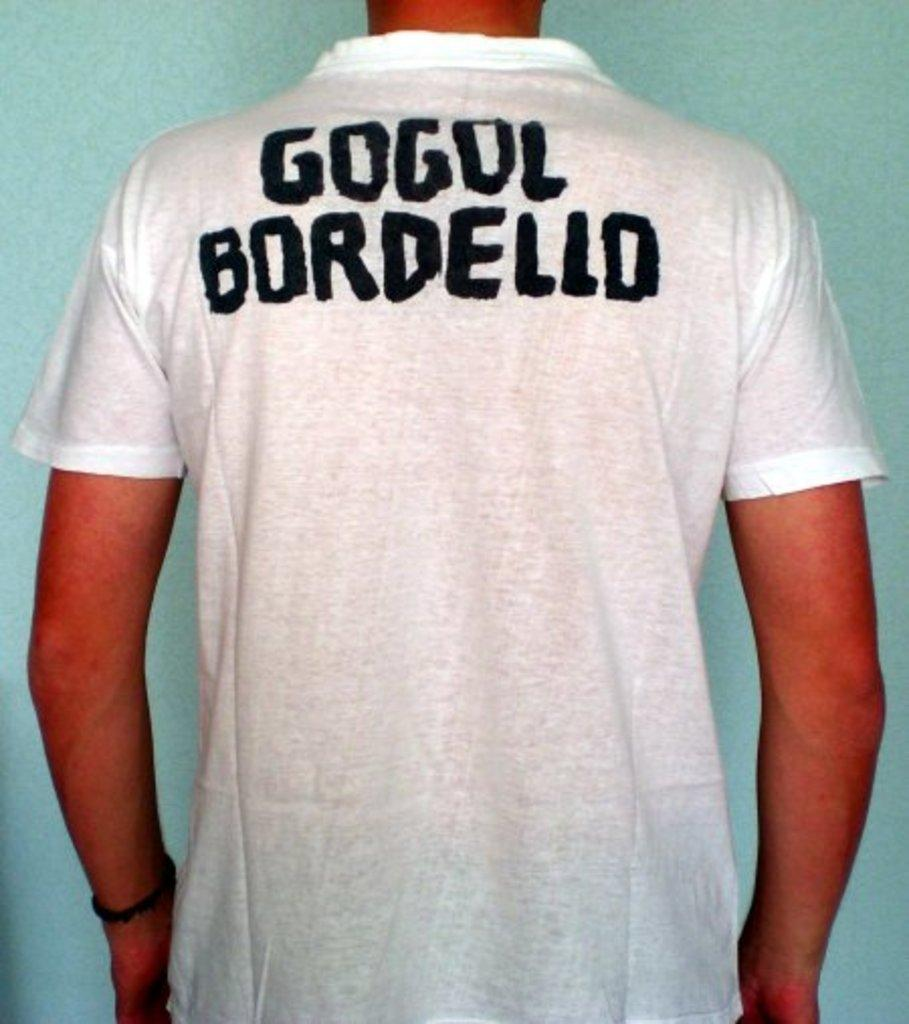Provide a one-sentence caption for the provided image. A man is wearing a white shirt that says Gogol Bordello on the back. 